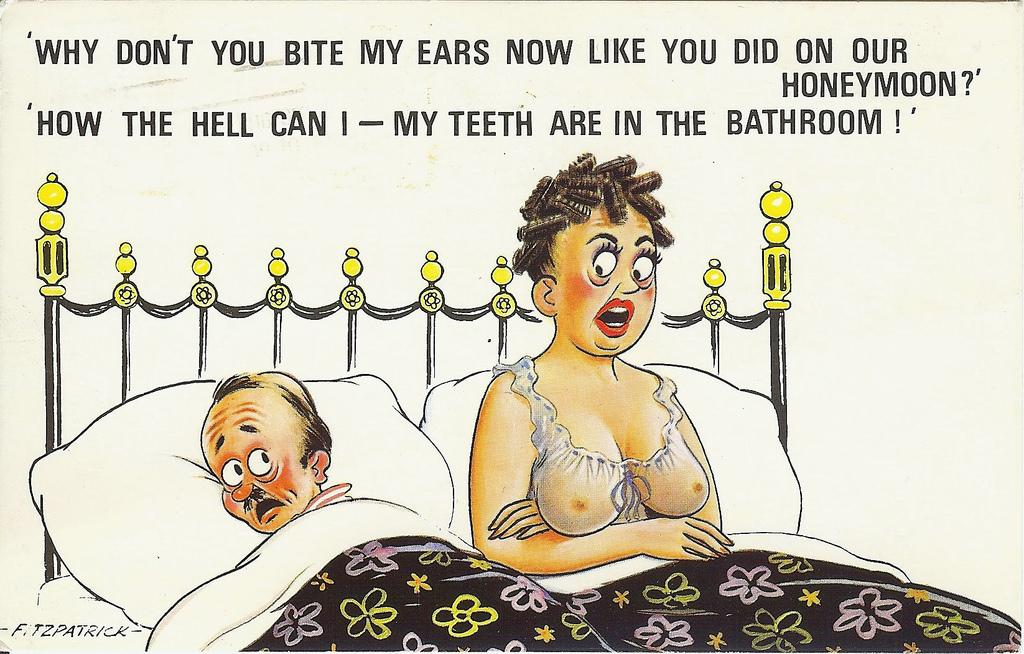What is the main subject of the image? There is a picture in the image. Who or what can be seen in the picture? The picture contains a man and a woman. Where are the man and woman located in the picture? The man and woman are on a bed. What is written or displayed at the top of the image? There is text at the top of the image. How many pizzas are being flown by the kite in the image? There are no pizzas or kites present in the image. What is the chance of the man and woman winning a lottery in the image? There is no information about a lottery or any chance of winning in the image. 